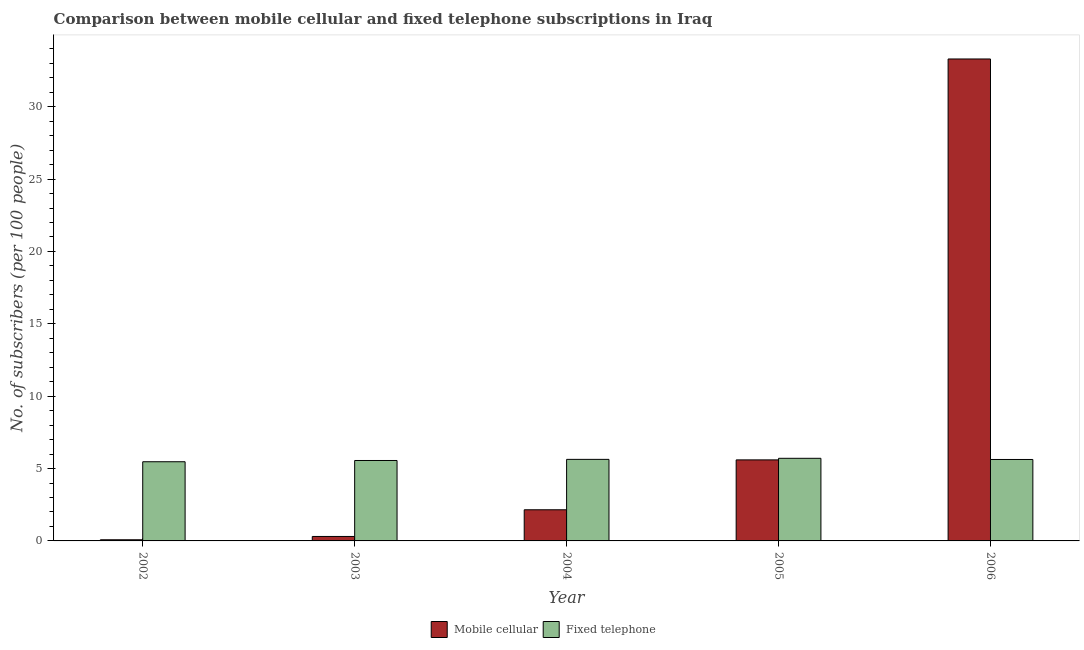How many different coloured bars are there?
Offer a very short reply. 2. Are the number of bars per tick equal to the number of legend labels?
Offer a terse response. Yes. How many bars are there on the 1st tick from the left?
Your answer should be compact. 2. In how many cases, is the number of bars for a given year not equal to the number of legend labels?
Your response must be concise. 0. What is the number of fixed telephone subscribers in 2003?
Provide a succinct answer. 5.56. Across all years, what is the maximum number of fixed telephone subscribers?
Offer a very short reply. 5.71. Across all years, what is the minimum number of fixed telephone subscribers?
Ensure brevity in your answer.  5.47. In which year was the number of mobile cellular subscribers maximum?
Give a very brief answer. 2006. What is the total number of fixed telephone subscribers in the graph?
Offer a terse response. 28. What is the difference between the number of fixed telephone subscribers in 2003 and that in 2005?
Your response must be concise. -0.15. What is the difference between the number of fixed telephone subscribers in 2003 and the number of mobile cellular subscribers in 2002?
Ensure brevity in your answer.  0.09. What is the average number of fixed telephone subscribers per year?
Give a very brief answer. 5.6. In the year 2006, what is the difference between the number of mobile cellular subscribers and number of fixed telephone subscribers?
Make the answer very short. 0. What is the ratio of the number of fixed telephone subscribers in 2003 to that in 2006?
Give a very brief answer. 0.99. What is the difference between the highest and the second highest number of mobile cellular subscribers?
Your answer should be compact. 27.7. What is the difference between the highest and the lowest number of fixed telephone subscribers?
Provide a short and direct response. 0.24. In how many years, is the number of mobile cellular subscribers greater than the average number of mobile cellular subscribers taken over all years?
Offer a terse response. 1. Is the sum of the number of fixed telephone subscribers in 2003 and 2006 greater than the maximum number of mobile cellular subscribers across all years?
Keep it short and to the point. Yes. What does the 1st bar from the left in 2002 represents?
Keep it short and to the point. Mobile cellular. What does the 1st bar from the right in 2003 represents?
Ensure brevity in your answer.  Fixed telephone. Are all the bars in the graph horizontal?
Offer a terse response. No. Are the values on the major ticks of Y-axis written in scientific E-notation?
Your answer should be very brief. No. Does the graph contain any zero values?
Your answer should be compact. No. Where does the legend appear in the graph?
Offer a very short reply. Bottom center. How are the legend labels stacked?
Give a very brief answer. Horizontal. What is the title of the graph?
Ensure brevity in your answer.  Comparison between mobile cellular and fixed telephone subscriptions in Iraq. What is the label or title of the Y-axis?
Your response must be concise. No. of subscribers (per 100 people). What is the No. of subscribers (per 100 people) of Mobile cellular in 2002?
Your answer should be very brief. 0.08. What is the No. of subscribers (per 100 people) of Fixed telephone in 2002?
Your answer should be very brief. 5.47. What is the No. of subscribers (per 100 people) of Mobile cellular in 2003?
Make the answer very short. 0.31. What is the No. of subscribers (per 100 people) in Fixed telephone in 2003?
Offer a very short reply. 5.56. What is the No. of subscribers (per 100 people) in Mobile cellular in 2004?
Offer a terse response. 2.15. What is the No. of subscribers (per 100 people) of Fixed telephone in 2004?
Your answer should be very brief. 5.63. What is the No. of subscribers (per 100 people) of Mobile cellular in 2005?
Ensure brevity in your answer.  5.6. What is the No. of subscribers (per 100 people) of Fixed telephone in 2005?
Your answer should be very brief. 5.71. What is the No. of subscribers (per 100 people) in Mobile cellular in 2006?
Make the answer very short. 33.3. What is the No. of subscribers (per 100 people) of Fixed telephone in 2006?
Provide a short and direct response. 5.63. Across all years, what is the maximum No. of subscribers (per 100 people) in Mobile cellular?
Give a very brief answer. 33.3. Across all years, what is the maximum No. of subscribers (per 100 people) in Fixed telephone?
Provide a short and direct response. 5.71. Across all years, what is the minimum No. of subscribers (per 100 people) of Mobile cellular?
Offer a terse response. 0.08. Across all years, what is the minimum No. of subscribers (per 100 people) in Fixed telephone?
Your answer should be compact. 5.47. What is the total No. of subscribers (per 100 people) of Mobile cellular in the graph?
Your answer should be very brief. 41.44. What is the total No. of subscribers (per 100 people) of Fixed telephone in the graph?
Give a very brief answer. 28. What is the difference between the No. of subscribers (per 100 people) of Mobile cellular in 2002 and that in 2003?
Make the answer very short. -0.23. What is the difference between the No. of subscribers (per 100 people) of Fixed telephone in 2002 and that in 2003?
Offer a very short reply. -0.09. What is the difference between the No. of subscribers (per 100 people) in Mobile cellular in 2002 and that in 2004?
Provide a succinct answer. -2.07. What is the difference between the No. of subscribers (per 100 people) in Fixed telephone in 2002 and that in 2004?
Your answer should be very brief. -0.16. What is the difference between the No. of subscribers (per 100 people) of Mobile cellular in 2002 and that in 2005?
Your answer should be compact. -5.52. What is the difference between the No. of subscribers (per 100 people) in Fixed telephone in 2002 and that in 2005?
Provide a succinct answer. -0.24. What is the difference between the No. of subscribers (per 100 people) of Mobile cellular in 2002 and that in 2006?
Your answer should be compact. -33.22. What is the difference between the No. of subscribers (per 100 people) of Fixed telephone in 2002 and that in 2006?
Ensure brevity in your answer.  -0.16. What is the difference between the No. of subscribers (per 100 people) of Mobile cellular in 2003 and that in 2004?
Offer a terse response. -1.84. What is the difference between the No. of subscribers (per 100 people) in Fixed telephone in 2003 and that in 2004?
Make the answer very short. -0.08. What is the difference between the No. of subscribers (per 100 people) in Mobile cellular in 2003 and that in 2005?
Make the answer very short. -5.29. What is the difference between the No. of subscribers (per 100 people) in Fixed telephone in 2003 and that in 2005?
Your answer should be compact. -0.15. What is the difference between the No. of subscribers (per 100 people) in Mobile cellular in 2003 and that in 2006?
Your answer should be very brief. -32.99. What is the difference between the No. of subscribers (per 100 people) of Fixed telephone in 2003 and that in 2006?
Offer a very short reply. -0.07. What is the difference between the No. of subscribers (per 100 people) in Mobile cellular in 2004 and that in 2005?
Offer a very short reply. -3.45. What is the difference between the No. of subscribers (per 100 people) in Fixed telephone in 2004 and that in 2005?
Your answer should be compact. -0.07. What is the difference between the No. of subscribers (per 100 people) of Mobile cellular in 2004 and that in 2006?
Your answer should be very brief. -31.15. What is the difference between the No. of subscribers (per 100 people) in Fixed telephone in 2004 and that in 2006?
Your answer should be compact. 0.01. What is the difference between the No. of subscribers (per 100 people) in Mobile cellular in 2005 and that in 2006?
Your response must be concise. -27.7. What is the difference between the No. of subscribers (per 100 people) of Fixed telephone in 2005 and that in 2006?
Offer a very short reply. 0.08. What is the difference between the No. of subscribers (per 100 people) in Mobile cellular in 2002 and the No. of subscribers (per 100 people) in Fixed telephone in 2003?
Give a very brief answer. -5.48. What is the difference between the No. of subscribers (per 100 people) in Mobile cellular in 2002 and the No. of subscribers (per 100 people) in Fixed telephone in 2004?
Offer a terse response. -5.56. What is the difference between the No. of subscribers (per 100 people) of Mobile cellular in 2002 and the No. of subscribers (per 100 people) of Fixed telephone in 2005?
Your answer should be compact. -5.63. What is the difference between the No. of subscribers (per 100 people) of Mobile cellular in 2002 and the No. of subscribers (per 100 people) of Fixed telephone in 2006?
Offer a terse response. -5.55. What is the difference between the No. of subscribers (per 100 people) of Mobile cellular in 2003 and the No. of subscribers (per 100 people) of Fixed telephone in 2004?
Provide a short and direct response. -5.33. What is the difference between the No. of subscribers (per 100 people) of Mobile cellular in 2003 and the No. of subscribers (per 100 people) of Fixed telephone in 2005?
Your answer should be compact. -5.4. What is the difference between the No. of subscribers (per 100 people) in Mobile cellular in 2003 and the No. of subscribers (per 100 people) in Fixed telephone in 2006?
Keep it short and to the point. -5.32. What is the difference between the No. of subscribers (per 100 people) of Mobile cellular in 2004 and the No. of subscribers (per 100 people) of Fixed telephone in 2005?
Give a very brief answer. -3.56. What is the difference between the No. of subscribers (per 100 people) of Mobile cellular in 2004 and the No. of subscribers (per 100 people) of Fixed telephone in 2006?
Make the answer very short. -3.48. What is the difference between the No. of subscribers (per 100 people) of Mobile cellular in 2005 and the No. of subscribers (per 100 people) of Fixed telephone in 2006?
Offer a very short reply. -0.03. What is the average No. of subscribers (per 100 people) in Mobile cellular per year?
Offer a very short reply. 8.29. What is the average No. of subscribers (per 100 people) in Fixed telephone per year?
Ensure brevity in your answer.  5.6. In the year 2002, what is the difference between the No. of subscribers (per 100 people) in Mobile cellular and No. of subscribers (per 100 people) in Fixed telephone?
Your answer should be very brief. -5.39. In the year 2003, what is the difference between the No. of subscribers (per 100 people) of Mobile cellular and No. of subscribers (per 100 people) of Fixed telephone?
Keep it short and to the point. -5.25. In the year 2004, what is the difference between the No. of subscribers (per 100 people) of Mobile cellular and No. of subscribers (per 100 people) of Fixed telephone?
Keep it short and to the point. -3.48. In the year 2005, what is the difference between the No. of subscribers (per 100 people) of Mobile cellular and No. of subscribers (per 100 people) of Fixed telephone?
Provide a succinct answer. -0.11. In the year 2006, what is the difference between the No. of subscribers (per 100 people) of Mobile cellular and No. of subscribers (per 100 people) of Fixed telephone?
Your response must be concise. 27.67. What is the ratio of the No. of subscribers (per 100 people) of Mobile cellular in 2002 to that in 2003?
Your answer should be very brief. 0.26. What is the ratio of the No. of subscribers (per 100 people) in Fixed telephone in 2002 to that in 2003?
Your answer should be compact. 0.98. What is the ratio of the No. of subscribers (per 100 people) of Mobile cellular in 2002 to that in 2004?
Give a very brief answer. 0.04. What is the ratio of the No. of subscribers (per 100 people) in Fixed telephone in 2002 to that in 2004?
Offer a terse response. 0.97. What is the ratio of the No. of subscribers (per 100 people) in Mobile cellular in 2002 to that in 2005?
Your response must be concise. 0.01. What is the ratio of the No. of subscribers (per 100 people) of Fixed telephone in 2002 to that in 2005?
Provide a succinct answer. 0.96. What is the ratio of the No. of subscribers (per 100 people) of Mobile cellular in 2002 to that in 2006?
Ensure brevity in your answer.  0. What is the ratio of the No. of subscribers (per 100 people) of Fixed telephone in 2002 to that in 2006?
Offer a terse response. 0.97. What is the ratio of the No. of subscribers (per 100 people) in Mobile cellular in 2003 to that in 2004?
Your response must be concise. 0.14. What is the ratio of the No. of subscribers (per 100 people) in Fixed telephone in 2003 to that in 2004?
Offer a terse response. 0.99. What is the ratio of the No. of subscribers (per 100 people) in Mobile cellular in 2003 to that in 2005?
Give a very brief answer. 0.06. What is the ratio of the No. of subscribers (per 100 people) in Fixed telephone in 2003 to that in 2005?
Ensure brevity in your answer.  0.97. What is the ratio of the No. of subscribers (per 100 people) in Mobile cellular in 2003 to that in 2006?
Provide a short and direct response. 0.01. What is the ratio of the No. of subscribers (per 100 people) in Fixed telephone in 2003 to that in 2006?
Give a very brief answer. 0.99. What is the ratio of the No. of subscribers (per 100 people) of Mobile cellular in 2004 to that in 2005?
Offer a very short reply. 0.38. What is the ratio of the No. of subscribers (per 100 people) of Fixed telephone in 2004 to that in 2005?
Your answer should be compact. 0.99. What is the ratio of the No. of subscribers (per 100 people) of Mobile cellular in 2004 to that in 2006?
Offer a very short reply. 0.06. What is the ratio of the No. of subscribers (per 100 people) in Mobile cellular in 2005 to that in 2006?
Your response must be concise. 0.17. What is the ratio of the No. of subscribers (per 100 people) of Fixed telephone in 2005 to that in 2006?
Make the answer very short. 1.01. What is the difference between the highest and the second highest No. of subscribers (per 100 people) in Mobile cellular?
Ensure brevity in your answer.  27.7. What is the difference between the highest and the second highest No. of subscribers (per 100 people) in Fixed telephone?
Offer a terse response. 0.07. What is the difference between the highest and the lowest No. of subscribers (per 100 people) in Mobile cellular?
Make the answer very short. 33.22. What is the difference between the highest and the lowest No. of subscribers (per 100 people) in Fixed telephone?
Give a very brief answer. 0.24. 